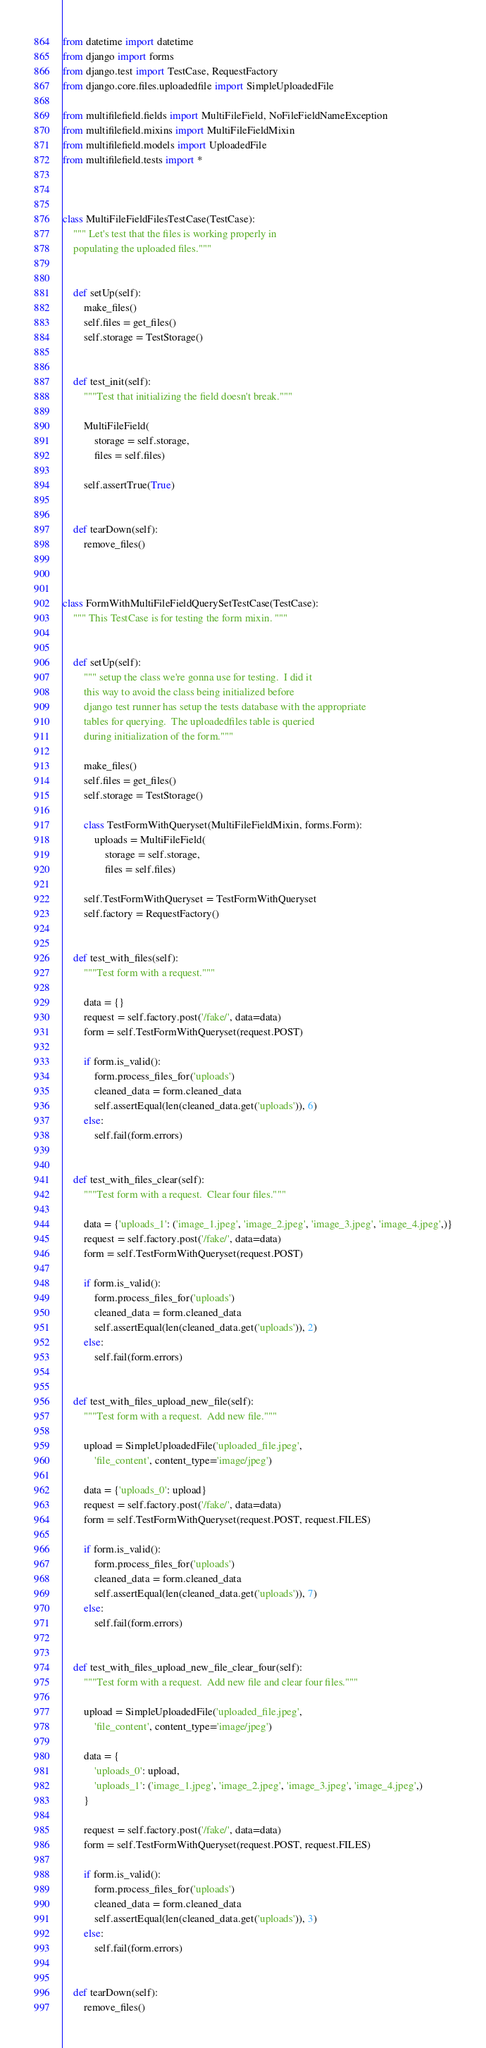Convert code to text. <code><loc_0><loc_0><loc_500><loc_500><_Python_>from datetime import datetime
from django import forms
from django.test import TestCase, RequestFactory
from django.core.files.uploadedfile import SimpleUploadedFile

from multifilefield.fields import MultiFileField, NoFileFieldNameException
from multifilefield.mixins import MultiFileFieldMixin
from multifilefield.models import UploadedFile
from multifilefield.tests import *



class MultiFileFieldFilesTestCase(TestCase):
    """ Let's test that the files is working properly in
    populating the uploaded files."""


    def setUp(self):
        make_files()
        self.files = get_files()
        self.storage = TestStorage()


    def test_init(self):
        """Test that initializing the field doesn't break."""

        MultiFileField(
            storage = self.storage,
            files = self.files)

        self.assertTrue(True)


    def tearDown(self):
        remove_files()



class FormWithMultiFileFieldQuerySetTestCase(TestCase):
    """ This TestCase is for testing the form mixin. """


    def setUp(self):
        """ setup the class we're gonna use for testing.  I did it
        this way to avoid the class being initialized before
        django test runner has setup the tests database with the appropriate
        tables for querying.  The uploadedfiles table is queried
        during initialization of the form."""

        make_files()
        self.files = get_files()
        self.storage = TestStorage()

        class TestFormWithQueryset(MultiFileFieldMixin, forms.Form):
            uploads = MultiFileField(
                storage = self.storage,
                files = self.files)

        self.TestFormWithQueryset = TestFormWithQueryset
        self.factory = RequestFactory()


    def test_with_files(self):
        """Test form with a request."""

        data = {}
        request = self.factory.post('/fake/', data=data)
        form = self.TestFormWithQueryset(request.POST)

        if form.is_valid():
            form.process_files_for('uploads')
            cleaned_data = form.cleaned_data
            self.assertEqual(len(cleaned_data.get('uploads')), 6)
        else:
            self.fail(form.errors)


    def test_with_files_clear(self):
        """Test form with a request.  Clear four files."""

        data = {'uploads_1': ('image_1.jpeg', 'image_2.jpeg', 'image_3.jpeg', 'image_4.jpeg',)}
        request = self.factory.post('/fake/', data=data)
        form = self.TestFormWithQueryset(request.POST)

        if form.is_valid():
            form.process_files_for('uploads')
            cleaned_data = form.cleaned_data
            self.assertEqual(len(cleaned_data.get('uploads')), 2)
        else:
            self.fail(form.errors)


    def test_with_files_upload_new_file(self):
        """Test form with a request.  Add new file."""

        upload = SimpleUploadedFile('uploaded_file.jpeg',
            'file_content', content_type='image/jpeg')

        data = {'uploads_0': upload}
        request = self.factory.post('/fake/', data=data)
        form = self.TestFormWithQueryset(request.POST, request.FILES)

        if form.is_valid():
            form.process_files_for('uploads')
            cleaned_data = form.cleaned_data
            self.assertEqual(len(cleaned_data.get('uploads')), 7)
        else:
            self.fail(form.errors)


    def test_with_files_upload_new_file_clear_four(self):
        """Test form with a request.  Add new file and clear four files."""

        upload = SimpleUploadedFile('uploaded_file.jpeg',
            'file_content', content_type='image/jpeg')

        data = {
            'uploads_0': upload,
            'uploads_1': ('image_1.jpeg', 'image_2.jpeg', 'image_3.jpeg', 'image_4.jpeg',)
        }

        request = self.factory.post('/fake/', data=data)
        form = self.TestFormWithQueryset(request.POST, request.FILES)

        if form.is_valid():
            form.process_files_for('uploads')
            cleaned_data = form.cleaned_data
            self.assertEqual(len(cleaned_data.get('uploads')), 3)
        else:
            self.fail(form.errors)


    def tearDown(self):
        remove_files()
</code> 